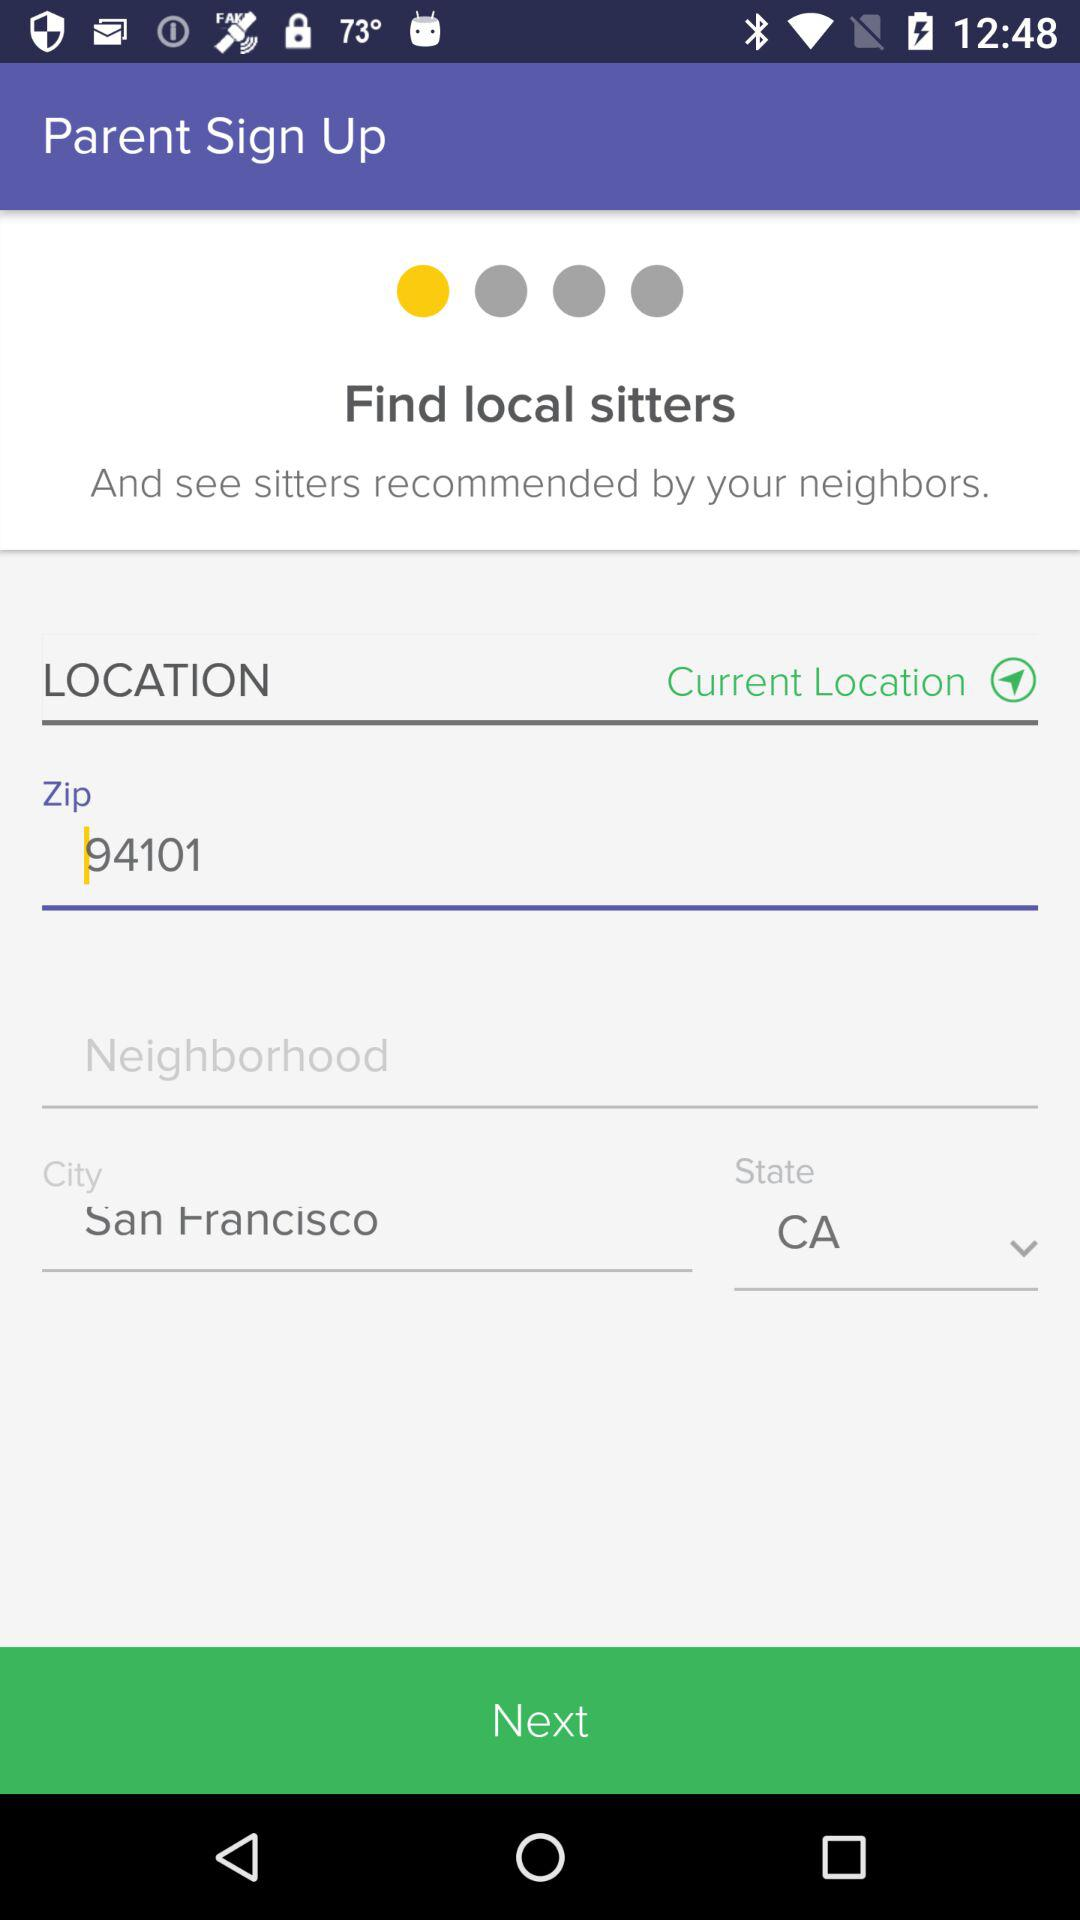Which city has been given? The given city is San Francisco. 